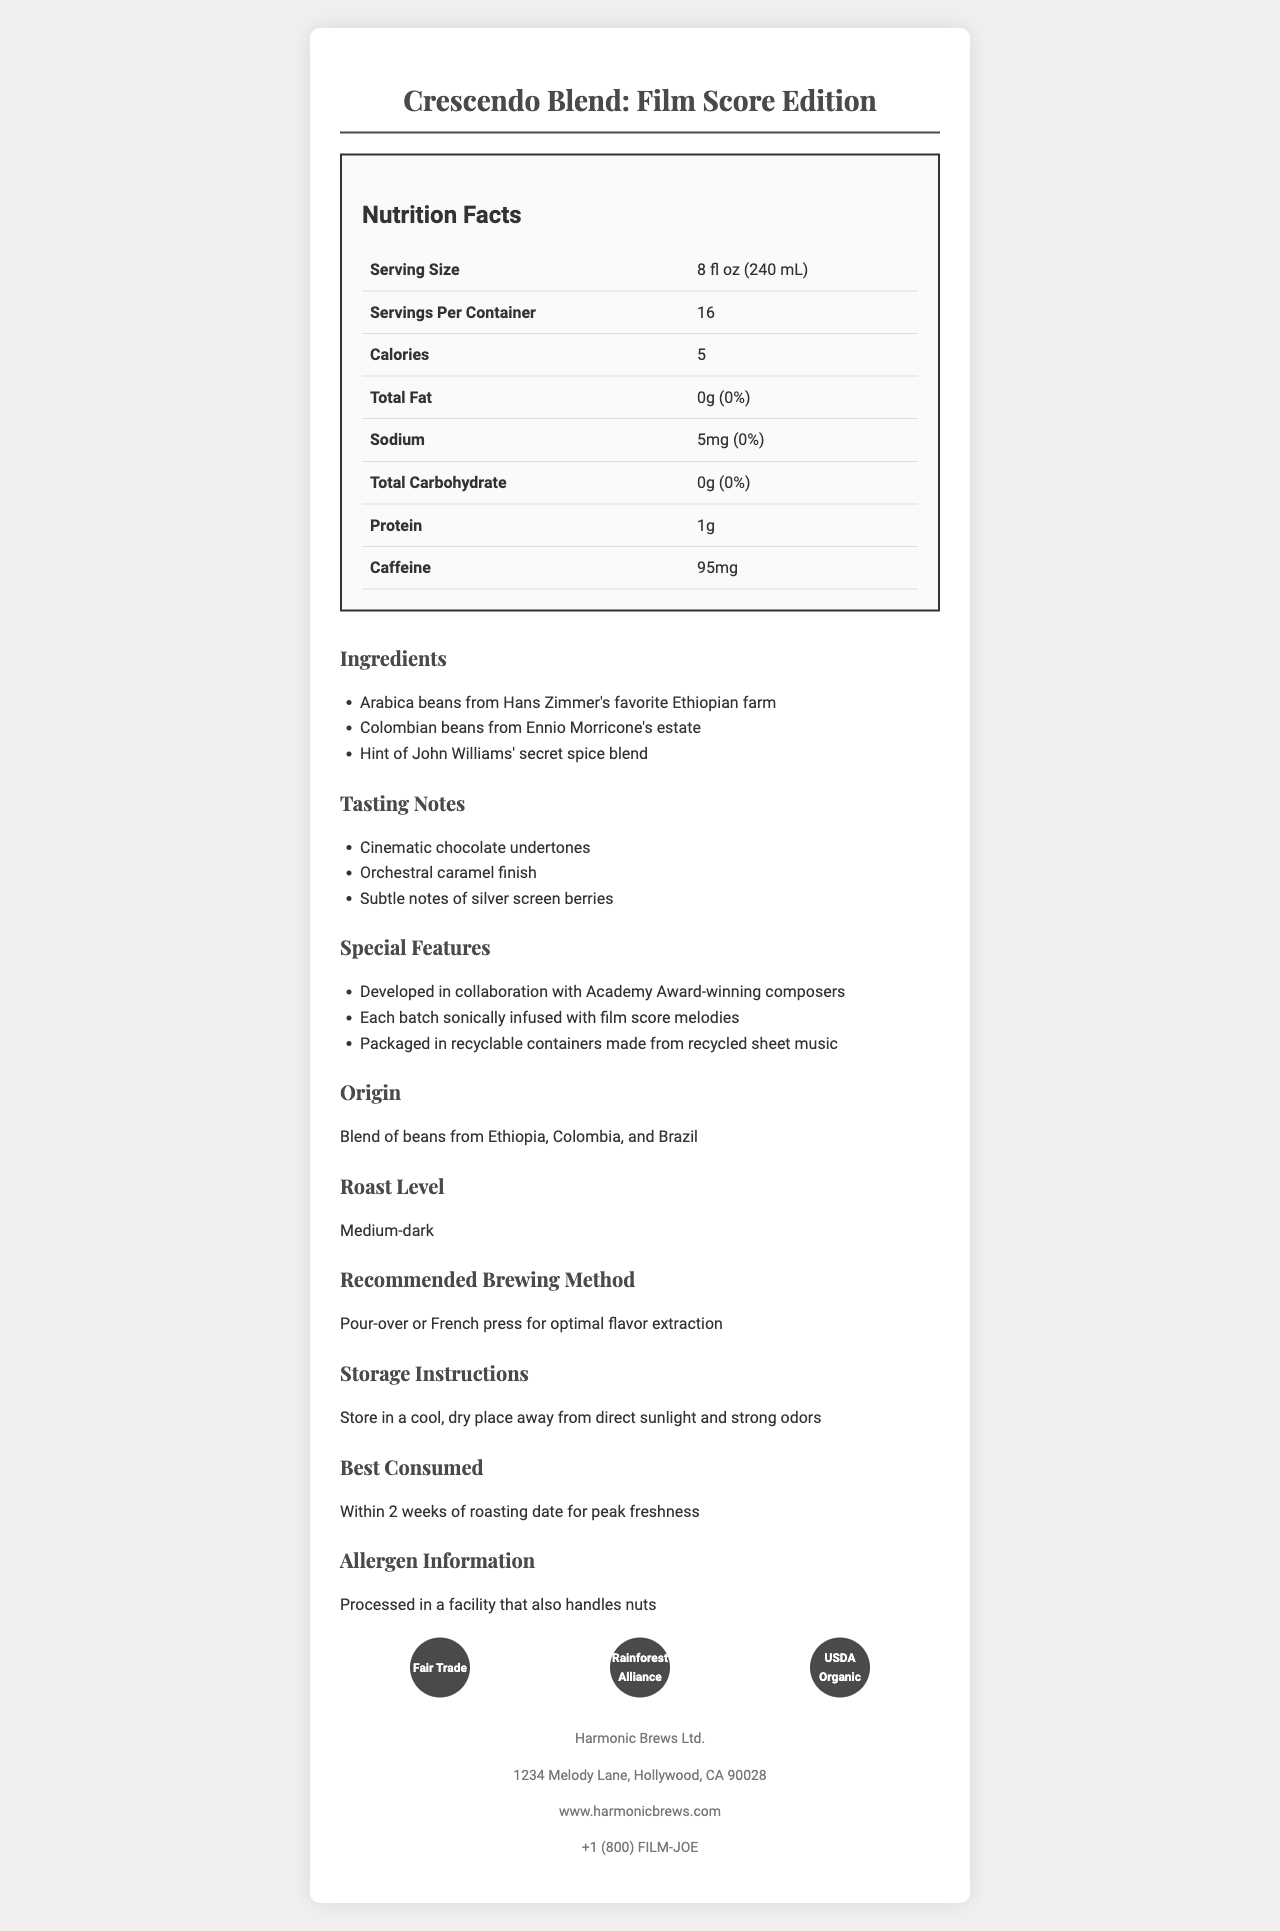what is the serving size? The serving size is listed in the "Serving Size" row of the nutrition facts table.
Answer: 8 fl oz (240 mL) how many servings are in each container? The number of servings per container is indicated in the "Servings Per Container" row of the nutrition facts table.
Answer: 16 what is the total carbohydrate content per serving? The total carbohydrate content is found in the "Total Carbohydrate" row of the nutrition facts table.
Answer: 0g what is the recommended brewing method for this coffee? The recommended brewing method is mentioned under the "Recommended Brewing Method" section of the document.
Answer: Pour-over or French press which certification is not listed for this product? A. Fair Trade B. Rainforest Alliance C. USDA Organic D. UTZ Certified The certifications listed are "Fair Trade," "Rainforest Alliance," and "USDA Organic." UTZ Certified is not mentioned.
Answer: D how much protein is in one serving of this coffee? The protein content is given in the "Protein" row of the nutrition facts table.
Answer: 1g who developed this coffee blend? The developers of the coffee blend are noted under "Special Features" which states that it was "developed in collaboration with Academy Award-winning composers."
Answer: Academy Award-winning composers is this coffee processed in a nut-free facility? The allergen info states "Processed in a facility that also handles nuts," indicating it is not nut-free.
Answer: No how much caffeine does one serving contain? The caffeine content per serving is listed at 95 mg in the nutrition facts table.
Answer: 95mg when is the best time to consume this coffee for peak freshness? The "Best Consumed" section states that the coffee is best consumed within 2 weeks of roasting date for peak freshness.
Answer: Within 2 weeks of roasting date which one of the following is a tasting note of this coffee blend? A. Nutty almond B. Silver screen berries C. Spicy cinnamon D. Floral jasmine One of the tasting notes listed includes "Subtle notes of silver screen berries."
Answer: B describe the main idea of this document. The document details the nutritional content, ingredients, certifications, and unique features of the coffee blend, including its origin, taste, and recommended consumption instructions.
Answer: This document provides the nutrition facts, ingredients, certifications, special features, and other relevant information for the specialty coffee blend named "Crescendo Blend: Film Score Edition," designed specifically for a film score production team. what is the total fat content and its daily value percentage? The "Total Fat" row in the nutrition facts table lists the fat content as 0g and the daily value percentage as 0%.
Answer: 0g, 0% what are the ingredients of this coffee blend? The ingredients are listed under the "Ingredients" section of the document.
Answer: Arabica beans from Hans Zimmer's favorite Ethiopian farm, Colombian beans from Ennio Morricone's estate, Hint of John Williams' secret spice blend can the exact caffeine content per container be determined from the available information? The document provides the caffeine content per serving (95mg) but does not specify the total caffeine content per container directly.
Answer: No where is Harmonic Brews Ltd. located? The company's address is listed in the "company_info" section at the bottom of the document.
Answer: 1234 Melody Lane, Hollywood, CA 90028 